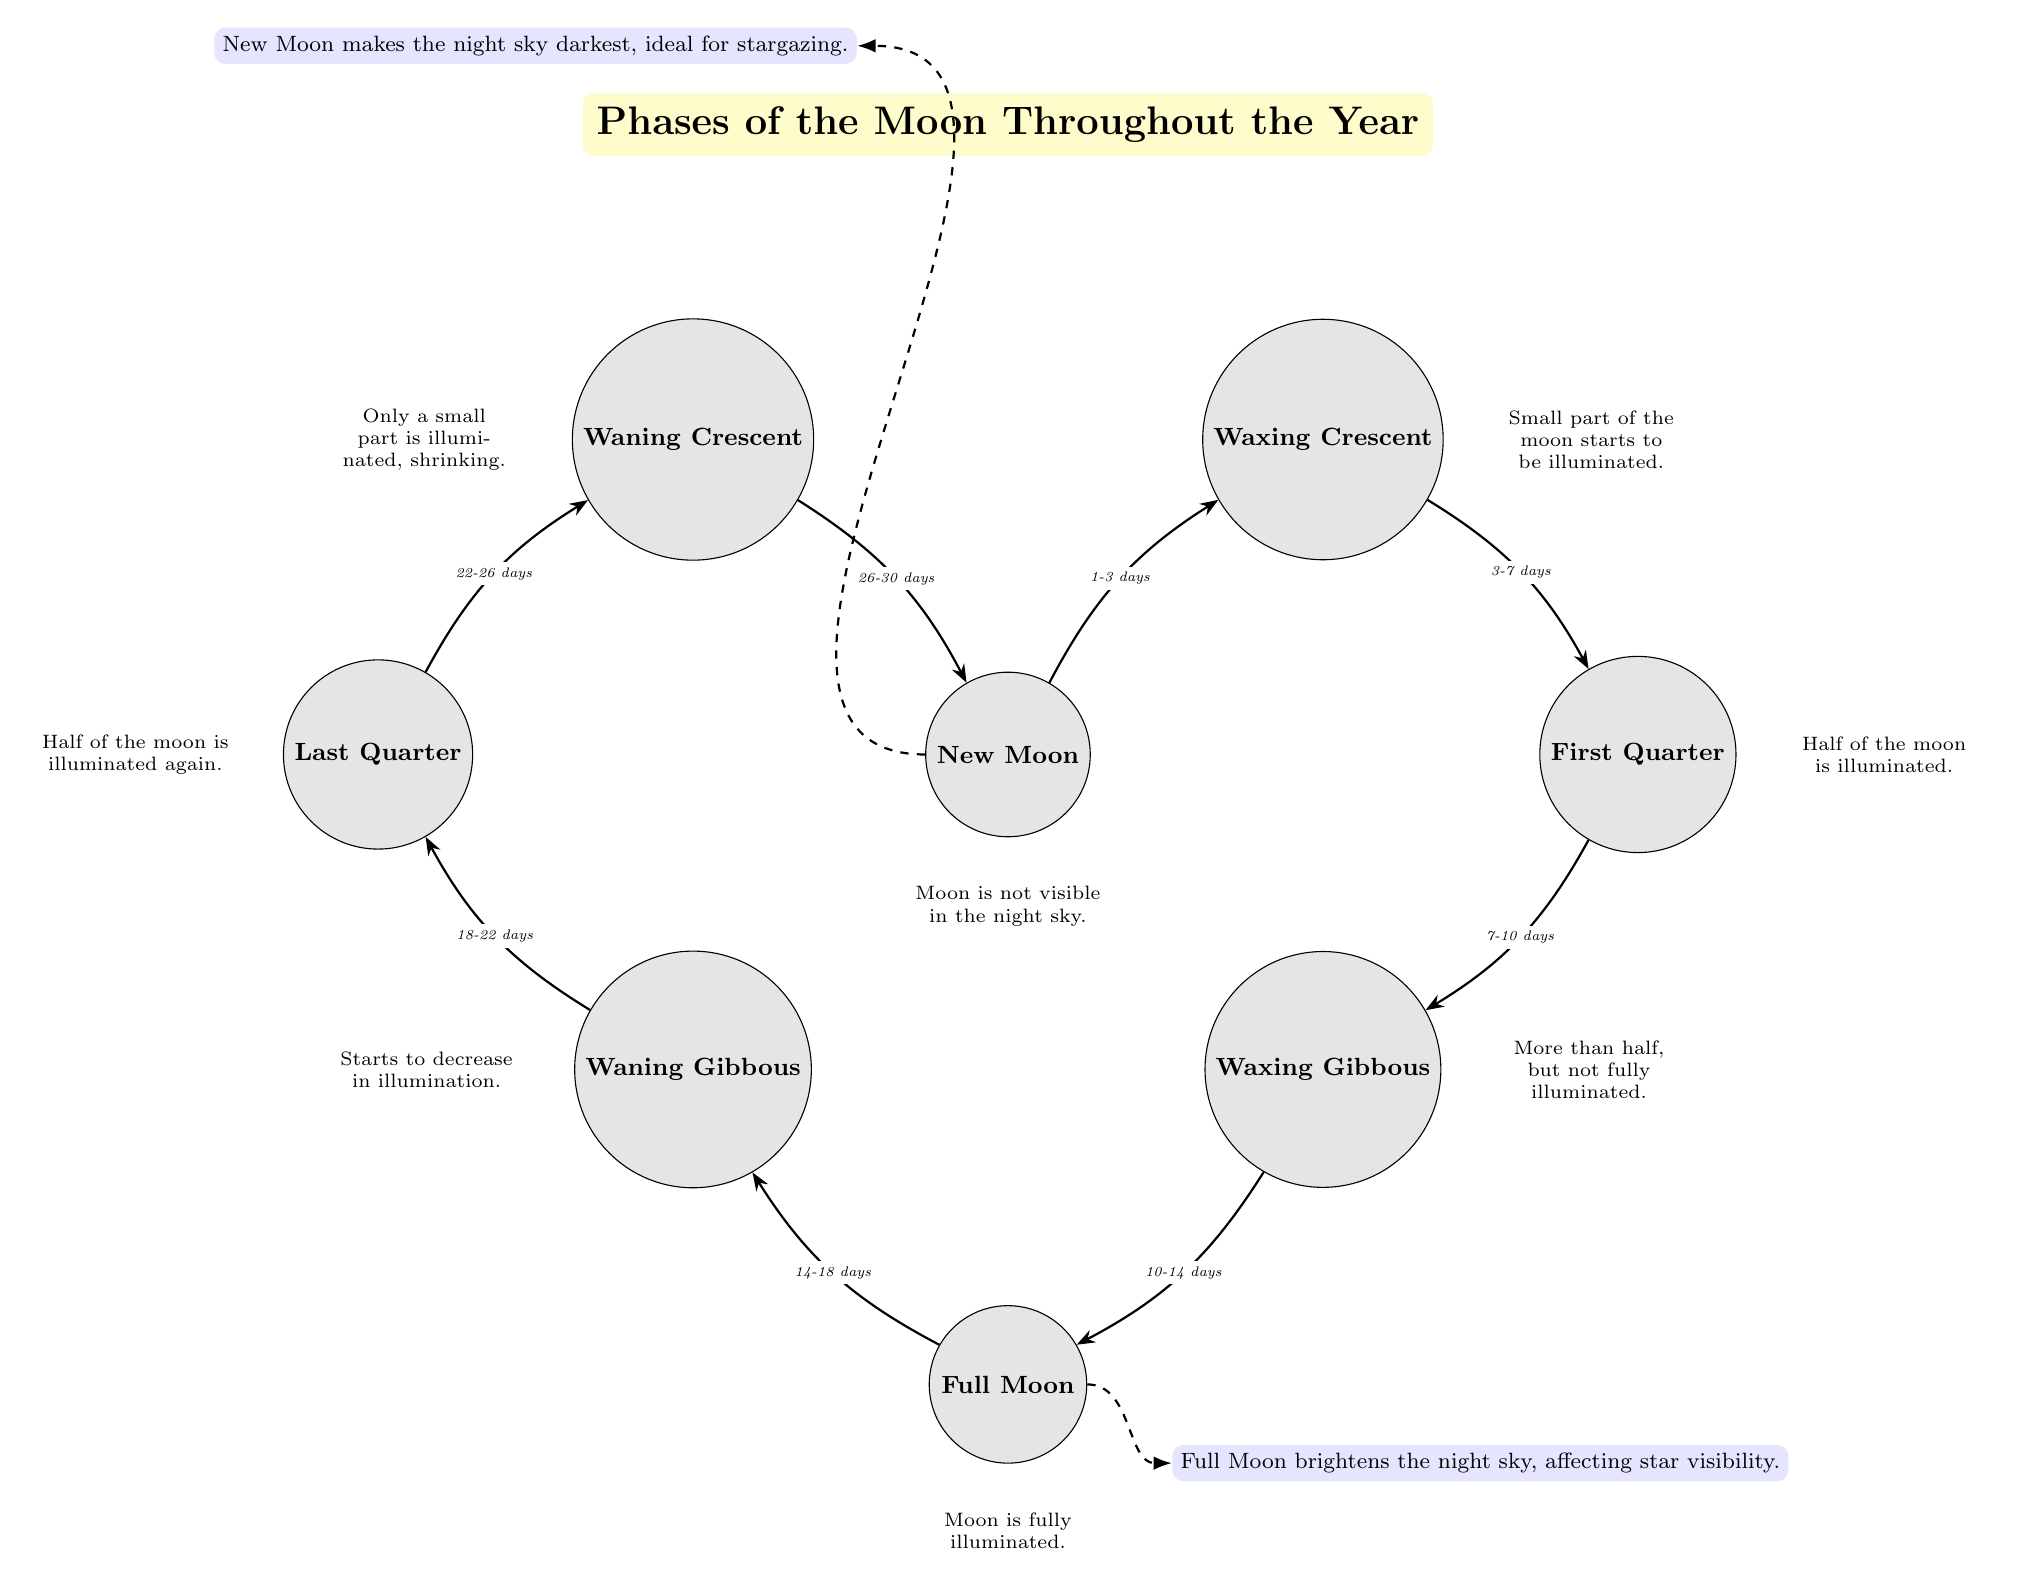What are the four main moon phases depicted in the diagram? The four main moon phases in the diagram are New Moon, Full Moon, First Quarter, and Last Quarter. These are labeled as distinct nodes and are central to the moon's cycle.
Answer: New Moon, Full Moon, First Quarter, Last Quarter How many days does it take to go from Full Moon to Waning Gibbous? The arrow connecting Full Moon to Waning Gibbous indicates that it takes 4 days to transition between these two phases, as labeled in the diagram.
Answer: 4 days What is the appearance of the moon during the Waxing Crescent phase? The description node below the Waxing Crescent mentions that a small part of the moon starts to be illuminated, indicating how it looks during this phase.
Answer: Small part illuminated Which moon phase is associated with the darkest night sky? According to the impact node related to New Moon, it is stated that the New Moon makes the night sky darkest, and thus this is the phase associated with darkest skies.
Answer: New Moon How many days is the entire lunar cycle represented in the diagram? By analyzing the arrows and the durations marked between each phase transition, it can be summed that the entire lunar cycle from New Moon back to New Moon takes 30 days.
Answer: 30 days What happens to the moon's visibility during a Full Moon? The diagram specifies that a Full Moon brightens the night sky, which directly impacts star visibility.
Answer: Brightens the night sky Which phase follows the First Quarter phase, according to the diagram? The arrow pointing from the First Quarter indicates that the next phase is the Waxing Gibbous, defining the sequential order of the moon phases.
Answer: Waxing Gibbous What is the effect of the New Moon on stargazing? The impact node for New Moon states that it makes the night sky darkest, which is ideal for stargazing, highlighting its beneficial effect for observing stars.
Answer: Ideal for stargazing 